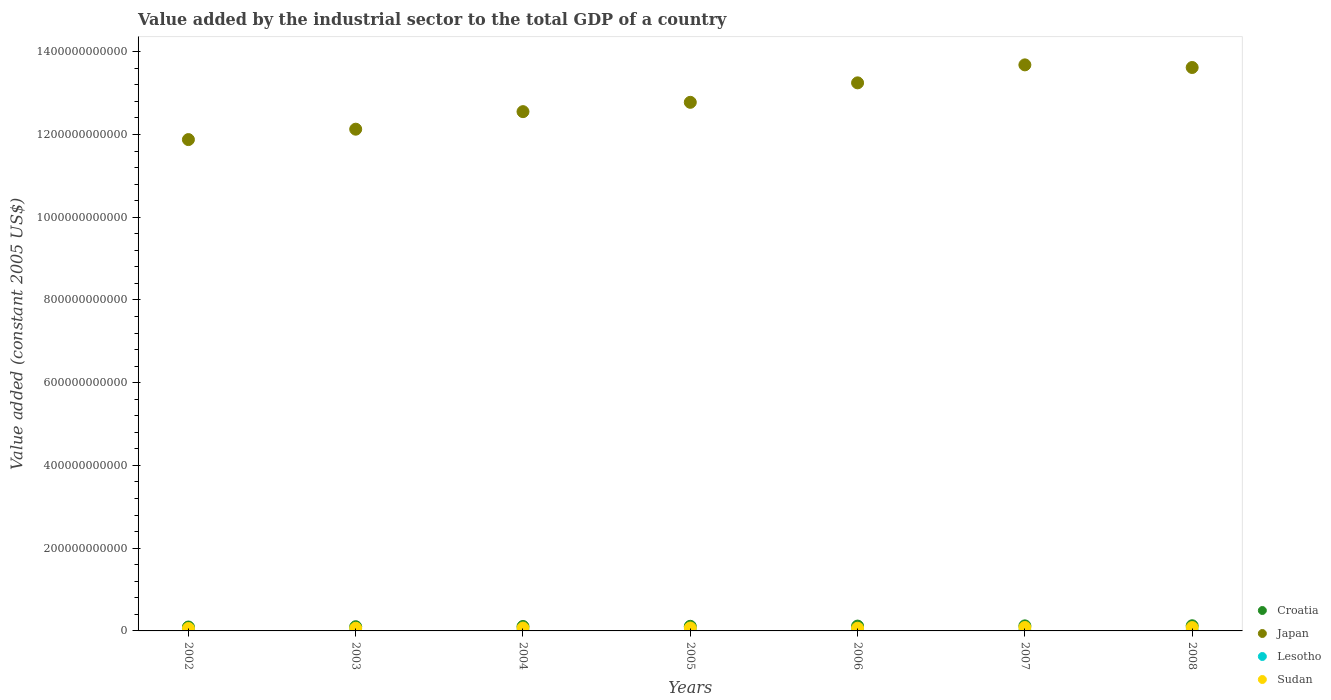Is the number of dotlines equal to the number of legend labels?
Keep it short and to the point. Yes. What is the value added by the industrial sector in Japan in 2007?
Ensure brevity in your answer.  1.37e+12. Across all years, what is the maximum value added by the industrial sector in Croatia?
Provide a short and direct response. 1.25e+1. Across all years, what is the minimum value added by the industrial sector in Croatia?
Your response must be concise. 9.44e+09. In which year was the value added by the industrial sector in Lesotho maximum?
Give a very brief answer. 2008. In which year was the value added by the industrial sector in Croatia minimum?
Keep it short and to the point. 2002. What is the total value added by the industrial sector in Lesotho in the graph?
Keep it short and to the point. 3.04e+09. What is the difference between the value added by the industrial sector in Sudan in 2003 and that in 2008?
Your response must be concise. -1.58e+09. What is the difference between the value added by the industrial sector in Japan in 2004 and the value added by the industrial sector in Lesotho in 2007?
Provide a succinct answer. 1.25e+12. What is the average value added by the industrial sector in Sudan per year?
Offer a terse response. 7.08e+09. In the year 2005, what is the difference between the value added by the industrial sector in Croatia and value added by the industrial sector in Japan?
Provide a short and direct response. -1.27e+12. In how many years, is the value added by the industrial sector in Lesotho greater than 240000000000 US$?
Your answer should be very brief. 0. What is the ratio of the value added by the industrial sector in Japan in 2005 to that in 2007?
Provide a succinct answer. 0.93. What is the difference between the highest and the second highest value added by the industrial sector in Sudan?
Offer a very short reply. 1.74e+08. What is the difference between the highest and the lowest value added by the industrial sector in Croatia?
Make the answer very short. 3.04e+09. In how many years, is the value added by the industrial sector in Japan greater than the average value added by the industrial sector in Japan taken over all years?
Provide a succinct answer. 3. Is the value added by the industrial sector in Croatia strictly greater than the value added by the industrial sector in Japan over the years?
Your answer should be compact. No. How many dotlines are there?
Make the answer very short. 4. What is the difference between two consecutive major ticks on the Y-axis?
Your answer should be very brief. 2.00e+11. Does the graph contain grids?
Offer a terse response. No. Where does the legend appear in the graph?
Your answer should be compact. Bottom right. How many legend labels are there?
Your answer should be compact. 4. What is the title of the graph?
Offer a terse response. Value added by the industrial sector to the total GDP of a country. What is the label or title of the X-axis?
Ensure brevity in your answer.  Years. What is the label or title of the Y-axis?
Keep it short and to the point. Value added (constant 2005 US$). What is the Value added (constant 2005 US$) in Croatia in 2002?
Offer a terse response. 9.44e+09. What is the Value added (constant 2005 US$) in Japan in 2002?
Keep it short and to the point. 1.19e+12. What is the Value added (constant 2005 US$) in Lesotho in 2002?
Keep it short and to the point. 3.73e+08. What is the Value added (constant 2005 US$) in Sudan in 2002?
Ensure brevity in your answer.  5.91e+09. What is the Value added (constant 2005 US$) of Croatia in 2003?
Ensure brevity in your answer.  1.02e+1. What is the Value added (constant 2005 US$) in Japan in 2003?
Your answer should be very brief. 1.21e+12. What is the Value added (constant 2005 US$) in Lesotho in 2003?
Your answer should be compact. 4.09e+08. What is the Value added (constant 2005 US$) in Sudan in 2003?
Your answer should be very brief. 6.54e+09. What is the Value added (constant 2005 US$) in Croatia in 2004?
Your answer should be very brief. 1.08e+1. What is the Value added (constant 2005 US$) of Japan in 2004?
Give a very brief answer. 1.26e+12. What is the Value added (constant 2005 US$) of Lesotho in 2004?
Make the answer very short. 4.16e+08. What is the Value added (constant 2005 US$) in Sudan in 2004?
Offer a terse response. 6.93e+09. What is the Value added (constant 2005 US$) in Croatia in 2005?
Provide a short and direct response. 1.12e+1. What is the Value added (constant 2005 US$) in Japan in 2005?
Your response must be concise. 1.28e+12. What is the Value added (constant 2005 US$) of Lesotho in 2005?
Provide a short and direct response. 4.16e+08. What is the Value added (constant 2005 US$) of Sudan in 2005?
Offer a terse response. 7.13e+09. What is the Value added (constant 2005 US$) of Croatia in 2006?
Your response must be concise. 1.17e+1. What is the Value added (constant 2005 US$) of Japan in 2006?
Your answer should be very brief. 1.32e+12. What is the Value added (constant 2005 US$) in Lesotho in 2006?
Make the answer very short. 4.47e+08. What is the Value added (constant 2005 US$) in Sudan in 2006?
Provide a short and direct response. 6.63e+09. What is the Value added (constant 2005 US$) in Croatia in 2007?
Provide a short and direct response. 1.22e+1. What is the Value added (constant 2005 US$) of Japan in 2007?
Your answer should be very brief. 1.37e+12. What is the Value added (constant 2005 US$) of Lesotho in 2007?
Your answer should be compact. 4.77e+08. What is the Value added (constant 2005 US$) in Sudan in 2007?
Make the answer very short. 8.29e+09. What is the Value added (constant 2005 US$) in Croatia in 2008?
Keep it short and to the point. 1.25e+1. What is the Value added (constant 2005 US$) of Japan in 2008?
Give a very brief answer. 1.36e+12. What is the Value added (constant 2005 US$) of Lesotho in 2008?
Your response must be concise. 5.03e+08. What is the Value added (constant 2005 US$) in Sudan in 2008?
Your answer should be compact. 8.12e+09. Across all years, what is the maximum Value added (constant 2005 US$) in Croatia?
Provide a short and direct response. 1.25e+1. Across all years, what is the maximum Value added (constant 2005 US$) in Japan?
Your response must be concise. 1.37e+12. Across all years, what is the maximum Value added (constant 2005 US$) of Lesotho?
Provide a short and direct response. 5.03e+08. Across all years, what is the maximum Value added (constant 2005 US$) in Sudan?
Your answer should be compact. 8.29e+09. Across all years, what is the minimum Value added (constant 2005 US$) in Croatia?
Make the answer very short. 9.44e+09. Across all years, what is the minimum Value added (constant 2005 US$) of Japan?
Provide a short and direct response. 1.19e+12. Across all years, what is the minimum Value added (constant 2005 US$) of Lesotho?
Provide a short and direct response. 3.73e+08. Across all years, what is the minimum Value added (constant 2005 US$) of Sudan?
Ensure brevity in your answer.  5.91e+09. What is the total Value added (constant 2005 US$) in Croatia in the graph?
Provide a succinct answer. 7.79e+1. What is the total Value added (constant 2005 US$) in Japan in the graph?
Provide a short and direct response. 8.99e+12. What is the total Value added (constant 2005 US$) in Lesotho in the graph?
Your answer should be compact. 3.04e+09. What is the total Value added (constant 2005 US$) in Sudan in the graph?
Give a very brief answer. 4.96e+1. What is the difference between the Value added (constant 2005 US$) in Croatia in 2002 and that in 2003?
Ensure brevity in your answer.  -7.32e+08. What is the difference between the Value added (constant 2005 US$) in Japan in 2002 and that in 2003?
Offer a very short reply. -2.51e+1. What is the difference between the Value added (constant 2005 US$) in Lesotho in 2002 and that in 2003?
Give a very brief answer. -3.61e+07. What is the difference between the Value added (constant 2005 US$) of Sudan in 2002 and that in 2003?
Ensure brevity in your answer.  -6.27e+08. What is the difference between the Value added (constant 2005 US$) in Croatia in 2002 and that in 2004?
Keep it short and to the point. -1.32e+09. What is the difference between the Value added (constant 2005 US$) in Japan in 2002 and that in 2004?
Offer a very short reply. -6.75e+1. What is the difference between the Value added (constant 2005 US$) in Lesotho in 2002 and that in 2004?
Provide a succinct answer. -4.29e+07. What is the difference between the Value added (constant 2005 US$) in Sudan in 2002 and that in 2004?
Ensure brevity in your answer.  -1.02e+09. What is the difference between the Value added (constant 2005 US$) of Croatia in 2002 and that in 2005?
Provide a short and direct response. -1.73e+09. What is the difference between the Value added (constant 2005 US$) in Japan in 2002 and that in 2005?
Your answer should be very brief. -9.01e+1. What is the difference between the Value added (constant 2005 US$) of Lesotho in 2002 and that in 2005?
Your response must be concise. -4.34e+07. What is the difference between the Value added (constant 2005 US$) of Sudan in 2002 and that in 2005?
Offer a terse response. -1.22e+09. What is the difference between the Value added (constant 2005 US$) of Croatia in 2002 and that in 2006?
Offer a terse response. -2.24e+09. What is the difference between the Value added (constant 2005 US$) in Japan in 2002 and that in 2006?
Keep it short and to the point. -1.37e+11. What is the difference between the Value added (constant 2005 US$) in Lesotho in 2002 and that in 2006?
Your response must be concise. -7.40e+07. What is the difference between the Value added (constant 2005 US$) of Sudan in 2002 and that in 2006?
Your answer should be very brief. -7.18e+08. What is the difference between the Value added (constant 2005 US$) of Croatia in 2002 and that in 2007?
Your answer should be very brief. -2.79e+09. What is the difference between the Value added (constant 2005 US$) of Japan in 2002 and that in 2007?
Your answer should be very brief. -1.81e+11. What is the difference between the Value added (constant 2005 US$) in Lesotho in 2002 and that in 2007?
Give a very brief answer. -1.04e+08. What is the difference between the Value added (constant 2005 US$) of Sudan in 2002 and that in 2007?
Provide a succinct answer. -2.38e+09. What is the difference between the Value added (constant 2005 US$) of Croatia in 2002 and that in 2008?
Offer a terse response. -3.04e+09. What is the difference between the Value added (constant 2005 US$) in Japan in 2002 and that in 2008?
Your answer should be compact. -1.74e+11. What is the difference between the Value added (constant 2005 US$) in Lesotho in 2002 and that in 2008?
Your answer should be very brief. -1.30e+08. What is the difference between the Value added (constant 2005 US$) in Sudan in 2002 and that in 2008?
Make the answer very short. -2.21e+09. What is the difference between the Value added (constant 2005 US$) of Croatia in 2003 and that in 2004?
Make the answer very short. -5.92e+08. What is the difference between the Value added (constant 2005 US$) of Japan in 2003 and that in 2004?
Provide a short and direct response. -4.24e+1. What is the difference between the Value added (constant 2005 US$) of Lesotho in 2003 and that in 2004?
Your answer should be very brief. -6.88e+06. What is the difference between the Value added (constant 2005 US$) of Sudan in 2003 and that in 2004?
Offer a terse response. -3.95e+08. What is the difference between the Value added (constant 2005 US$) of Croatia in 2003 and that in 2005?
Ensure brevity in your answer.  -9.95e+08. What is the difference between the Value added (constant 2005 US$) in Japan in 2003 and that in 2005?
Your answer should be very brief. -6.49e+1. What is the difference between the Value added (constant 2005 US$) in Lesotho in 2003 and that in 2005?
Make the answer very short. -7.39e+06. What is the difference between the Value added (constant 2005 US$) of Sudan in 2003 and that in 2005?
Your answer should be compact. -5.90e+08. What is the difference between the Value added (constant 2005 US$) of Croatia in 2003 and that in 2006?
Keep it short and to the point. -1.51e+09. What is the difference between the Value added (constant 2005 US$) of Japan in 2003 and that in 2006?
Your response must be concise. -1.12e+11. What is the difference between the Value added (constant 2005 US$) in Lesotho in 2003 and that in 2006?
Ensure brevity in your answer.  -3.79e+07. What is the difference between the Value added (constant 2005 US$) of Sudan in 2003 and that in 2006?
Make the answer very short. -9.01e+07. What is the difference between the Value added (constant 2005 US$) in Croatia in 2003 and that in 2007?
Your answer should be compact. -2.06e+09. What is the difference between the Value added (constant 2005 US$) of Japan in 2003 and that in 2007?
Give a very brief answer. -1.55e+11. What is the difference between the Value added (constant 2005 US$) of Lesotho in 2003 and that in 2007?
Offer a terse response. -6.76e+07. What is the difference between the Value added (constant 2005 US$) of Sudan in 2003 and that in 2007?
Ensure brevity in your answer.  -1.75e+09. What is the difference between the Value added (constant 2005 US$) of Croatia in 2003 and that in 2008?
Keep it short and to the point. -2.31e+09. What is the difference between the Value added (constant 2005 US$) of Japan in 2003 and that in 2008?
Your answer should be compact. -1.49e+11. What is the difference between the Value added (constant 2005 US$) in Lesotho in 2003 and that in 2008?
Offer a very short reply. -9.36e+07. What is the difference between the Value added (constant 2005 US$) of Sudan in 2003 and that in 2008?
Provide a short and direct response. -1.58e+09. What is the difference between the Value added (constant 2005 US$) of Croatia in 2004 and that in 2005?
Provide a succinct answer. -4.03e+08. What is the difference between the Value added (constant 2005 US$) of Japan in 2004 and that in 2005?
Your answer should be compact. -2.25e+1. What is the difference between the Value added (constant 2005 US$) in Lesotho in 2004 and that in 2005?
Give a very brief answer. -5.01e+05. What is the difference between the Value added (constant 2005 US$) in Sudan in 2004 and that in 2005?
Your response must be concise. -1.94e+08. What is the difference between the Value added (constant 2005 US$) of Croatia in 2004 and that in 2006?
Give a very brief answer. -9.14e+08. What is the difference between the Value added (constant 2005 US$) in Japan in 2004 and that in 2006?
Provide a succinct answer. -6.96e+1. What is the difference between the Value added (constant 2005 US$) of Lesotho in 2004 and that in 2006?
Ensure brevity in your answer.  -3.11e+07. What is the difference between the Value added (constant 2005 US$) in Sudan in 2004 and that in 2006?
Offer a terse response. 3.05e+08. What is the difference between the Value added (constant 2005 US$) of Croatia in 2004 and that in 2007?
Offer a very short reply. -1.47e+09. What is the difference between the Value added (constant 2005 US$) in Japan in 2004 and that in 2007?
Offer a terse response. -1.13e+11. What is the difference between the Value added (constant 2005 US$) in Lesotho in 2004 and that in 2007?
Keep it short and to the point. -6.08e+07. What is the difference between the Value added (constant 2005 US$) of Sudan in 2004 and that in 2007?
Your response must be concise. -1.36e+09. What is the difference between the Value added (constant 2005 US$) of Croatia in 2004 and that in 2008?
Keep it short and to the point. -1.72e+09. What is the difference between the Value added (constant 2005 US$) of Japan in 2004 and that in 2008?
Offer a very short reply. -1.07e+11. What is the difference between the Value added (constant 2005 US$) in Lesotho in 2004 and that in 2008?
Your answer should be compact. -8.67e+07. What is the difference between the Value added (constant 2005 US$) of Sudan in 2004 and that in 2008?
Your answer should be compact. -1.18e+09. What is the difference between the Value added (constant 2005 US$) in Croatia in 2005 and that in 2006?
Offer a terse response. -5.11e+08. What is the difference between the Value added (constant 2005 US$) of Japan in 2005 and that in 2006?
Make the answer very short. -4.71e+1. What is the difference between the Value added (constant 2005 US$) in Lesotho in 2005 and that in 2006?
Make the answer very short. -3.06e+07. What is the difference between the Value added (constant 2005 US$) of Sudan in 2005 and that in 2006?
Provide a succinct answer. 5.00e+08. What is the difference between the Value added (constant 2005 US$) in Croatia in 2005 and that in 2007?
Provide a short and direct response. -1.07e+09. What is the difference between the Value added (constant 2005 US$) in Japan in 2005 and that in 2007?
Give a very brief answer. -9.05e+1. What is the difference between the Value added (constant 2005 US$) in Lesotho in 2005 and that in 2007?
Provide a succinct answer. -6.03e+07. What is the difference between the Value added (constant 2005 US$) of Sudan in 2005 and that in 2007?
Your answer should be very brief. -1.16e+09. What is the difference between the Value added (constant 2005 US$) in Croatia in 2005 and that in 2008?
Provide a short and direct response. -1.32e+09. What is the difference between the Value added (constant 2005 US$) in Japan in 2005 and that in 2008?
Provide a succinct answer. -8.42e+1. What is the difference between the Value added (constant 2005 US$) of Lesotho in 2005 and that in 2008?
Keep it short and to the point. -8.62e+07. What is the difference between the Value added (constant 2005 US$) of Sudan in 2005 and that in 2008?
Make the answer very short. -9.90e+08. What is the difference between the Value added (constant 2005 US$) in Croatia in 2006 and that in 2007?
Ensure brevity in your answer.  -5.57e+08. What is the difference between the Value added (constant 2005 US$) of Japan in 2006 and that in 2007?
Provide a succinct answer. -4.35e+1. What is the difference between the Value added (constant 2005 US$) in Lesotho in 2006 and that in 2007?
Your answer should be very brief. -2.97e+07. What is the difference between the Value added (constant 2005 US$) of Sudan in 2006 and that in 2007?
Make the answer very short. -1.66e+09. What is the difference between the Value added (constant 2005 US$) in Croatia in 2006 and that in 2008?
Keep it short and to the point. -8.07e+08. What is the difference between the Value added (constant 2005 US$) in Japan in 2006 and that in 2008?
Your answer should be very brief. -3.71e+1. What is the difference between the Value added (constant 2005 US$) of Lesotho in 2006 and that in 2008?
Provide a succinct answer. -5.56e+07. What is the difference between the Value added (constant 2005 US$) of Sudan in 2006 and that in 2008?
Provide a succinct answer. -1.49e+09. What is the difference between the Value added (constant 2005 US$) in Croatia in 2007 and that in 2008?
Offer a terse response. -2.50e+08. What is the difference between the Value added (constant 2005 US$) of Japan in 2007 and that in 2008?
Keep it short and to the point. 6.36e+09. What is the difference between the Value added (constant 2005 US$) in Lesotho in 2007 and that in 2008?
Your answer should be very brief. -2.59e+07. What is the difference between the Value added (constant 2005 US$) of Sudan in 2007 and that in 2008?
Offer a terse response. 1.74e+08. What is the difference between the Value added (constant 2005 US$) in Croatia in 2002 and the Value added (constant 2005 US$) in Japan in 2003?
Your answer should be compact. -1.20e+12. What is the difference between the Value added (constant 2005 US$) of Croatia in 2002 and the Value added (constant 2005 US$) of Lesotho in 2003?
Your response must be concise. 9.03e+09. What is the difference between the Value added (constant 2005 US$) of Croatia in 2002 and the Value added (constant 2005 US$) of Sudan in 2003?
Offer a very short reply. 2.90e+09. What is the difference between the Value added (constant 2005 US$) of Japan in 2002 and the Value added (constant 2005 US$) of Lesotho in 2003?
Your response must be concise. 1.19e+12. What is the difference between the Value added (constant 2005 US$) of Japan in 2002 and the Value added (constant 2005 US$) of Sudan in 2003?
Offer a very short reply. 1.18e+12. What is the difference between the Value added (constant 2005 US$) in Lesotho in 2002 and the Value added (constant 2005 US$) in Sudan in 2003?
Your response must be concise. -6.17e+09. What is the difference between the Value added (constant 2005 US$) in Croatia in 2002 and the Value added (constant 2005 US$) in Japan in 2004?
Your answer should be compact. -1.25e+12. What is the difference between the Value added (constant 2005 US$) of Croatia in 2002 and the Value added (constant 2005 US$) of Lesotho in 2004?
Offer a very short reply. 9.02e+09. What is the difference between the Value added (constant 2005 US$) of Croatia in 2002 and the Value added (constant 2005 US$) of Sudan in 2004?
Provide a succinct answer. 2.50e+09. What is the difference between the Value added (constant 2005 US$) of Japan in 2002 and the Value added (constant 2005 US$) of Lesotho in 2004?
Give a very brief answer. 1.19e+12. What is the difference between the Value added (constant 2005 US$) of Japan in 2002 and the Value added (constant 2005 US$) of Sudan in 2004?
Provide a short and direct response. 1.18e+12. What is the difference between the Value added (constant 2005 US$) in Lesotho in 2002 and the Value added (constant 2005 US$) in Sudan in 2004?
Your answer should be very brief. -6.56e+09. What is the difference between the Value added (constant 2005 US$) of Croatia in 2002 and the Value added (constant 2005 US$) of Japan in 2005?
Give a very brief answer. -1.27e+12. What is the difference between the Value added (constant 2005 US$) of Croatia in 2002 and the Value added (constant 2005 US$) of Lesotho in 2005?
Give a very brief answer. 9.02e+09. What is the difference between the Value added (constant 2005 US$) in Croatia in 2002 and the Value added (constant 2005 US$) in Sudan in 2005?
Give a very brief answer. 2.31e+09. What is the difference between the Value added (constant 2005 US$) in Japan in 2002 and the Value added (constant 2005 US$) in Lesotho in 2005?
Provide a short and direct response. 1.19e+12. What is the difference between the Value added (constant 2005 US$) of Japan in 2002 and the Value added (constant 2005 US$) of Sudan in 2005?
Your answer should be compact. 1.18e+12. What is the difference between the Value added (constant 2005 US$) of Lesotho in 2002 and the Value added (constant 2005 US$) of Sudan in 2005?
Ensure brevity in your answer.  -6.76e+09. What is the difference between the Value added (constant 2005 US$) in Croatia in 2002 and the Value added (constant 2005 US$) in Japan in 2006?
Your answer should be very brief. -1.32e+12. What is the difference between the Value added (constant 2005 US$) of Croatia in 2002 and the Value added (constant 2005 US$) of Lesotho in 2006?
Keep it short and to the point. 8.99e+09. What is the difference between the Value added (constant 2005 US$) in Croatia in 2002 and the Value added (constant 2005 US$) in Sudan in 2006?
Provide a succinct answer. 2.81e+09. What is the difference between the Value added (constant 2005 US$) of Japan in 2002 and the Value added (constant 2005 US$) of Lesotho in 2006?
Keep it short and to the point. 1.19e+12. What is the difference between the Value added (constant 2005 US$) of Japan in 2002 and the Value added (constant 2005 US$) of Sudan in 2006?
Your response must be concise. 1.18e+12. What is the difference between the Value added (constant 2005 US$) of Lesotho in 2002 and the Value added (constant 2005 US$) of Sudan in 2006?
Provide a short and direct response. -6.26e+09. What is the difference between the Value added (constant 2005 US$) in Croatia in 2002 and the Value added (constant 2005 US$) in Japan in 2007?
Provide a succinct answer. -1.36e+12. What is the difference between the Value added (constant 2005 US$) of Croatia in 2002 and the Value added (constant 2005 US$) of Lesotho in 2007?
Give a very brief answer. 8.96e+09. What is the difference between the Value added (constant 2005 US$) of Croatia in 2002 and the Value added (constant 2005 US$) of Sudan in 2007?
Provide a succinct answer. 1.14e+09. What is the difference between the Value added (constant 2005 US$) in Japan in 2002 and the Value added (constant 2005 US$) in Lesotho in 2007?
Offer a terse response. 1.19e+12. What is the difference between the Value added (constant 2005 US$) of Japan in 2002 and the Value added (constant 2005 US$) of Sudan in 2007?
Ensure brevity in your answer.  1.18e+12. What is the difference between the Value added (constant 2005 US$) in Lesotho in 2002 and the Value added (constant 2005 US$) in Sudan in 2007?
Your response must be concise. -7.92e+09. What is the difference between the Value added (constant 2005 US$) in Croatia in 2002 and the Value added (constant 2005 US$) in Japan in 2008?
Keep it short and to the point. -1.35e+12. What is the difference between the Value added (constant 2005 US$) in Croatia in 2002 and the Value added (constant 2005 US$) in Lesotho in 2008?
Make the answer very short. 8.93e+09. What is the difference between the Value added (constant 2005 US$) of Croatia in 2002 and the Value added (constant 2005 US$) of Sudan in 2008?
Give a very brief answer. 1.32e+09. What is the difference between the Value added (constant 2005 US$) of Japan in 2002 and the Value added (constant 2005 US$) of Lesotho in 2008?
Provide a short and direct response. 1.19e+12. What is the difference between the Value added (constant 2005 US$) in Japan in 2002 and the Value added (constant 2005 US$) in Sudan in 2008?
Offer a very short reply. 1.18e+12. What is the difference between the Value added (constant 2005 US$) of Lesotho in 2002 and the Value added (constant 2005 US$) of Sudan in 2008?
Your answer should be compact. -7.75e+09. What is the difference between the Value added (constant 2005 US$) in Croatia in 2003 and the Value added (constant 2005 US$) in Japan in 2004?
Give a very brief answer. -1.25e+12. What is the difference between the Value added (constant 2005 US$) in Croatia in 2003 and the Value added (constant 2005 US$) in Lesotho in 2004?
Ensure brevity in your answer.  9.75e+09. What is the difference between the Value added (constant 2005 US$) in Croatia in 2003 and the Value added (constant 2005 US$) in Sudan in 2004?
Ensure brevity in your answer.  3.23e+09. What is the difference between the Value added (constant 2005 US$) in Japan in 2003 and the Value added (constant 2005 US$) in Lesotho in 2004?
Offer a very short reply. 1.21e+12. What is the difference between the Value added (constant 2005 US$) of Japan in 2003 and the Value added (constant 2005 US$) of Sudan in 2004?
Offer a very short reply. 1.21e+12. What is the difference between the Value added (constant 2005 US$) in Lesotho in 2003 and the Value added (constant 2005 US$) in Sudan in 2004?
Provide a succinct answer. -6.53e+09. What is the difference between the Value added (constant 2005 US$) of Croatia in 2003 and the Value added (constant 2005 US$) of Japan in 2005?
Offer a very short reply. -1.27e+12. What is the difference between the Value added (constant 2005 US$) of Croatia in 2003 and the Value added (constant 2005 US$) of Lesotho in 2005?
Your response must be concise. 9.75e+09. What is the difference between the Value added (constant 2005 US$) of Croatia in 2003 and the Value added (constant 2005 US$) of Sudan in 2005?
Keep it short and to the point. 3.04e+09. What is the difference between the Value added (constant 2005 US$) of Japan in 2003 and the Value added (constant 2005 US$) of Lesotho in 2005?
Give a very brief answer. 1.21e+12. What is the difference between the Value added (constant 2005 US$) of Japan in 2003 and the Value added (constant 2005 US$) of Sudan in 2005?
Your answer should be very brief. 1.21e+12. What is the difference between the Value added (constant 2005 US$) in Lesotho in 2003 and the Value added (constant 2005 US$) in Sudan in 2005?
Your answer should be compact. -6.72e+09. What is the difference between the Value added (constant 2005 US$) in Croatia in 2003 and the Value added (constant 2005 US$) in Japan in 2006?
Make the answer very short. -1.31e+12. What is the difference between the Value added (constant 2005 US$) of Croatia in 2003 and the Value added (constant 2005 US$) of Lesotho in 2006?
Your response must be concise. 9.72e+09. What is the difference between the Value added (constant 2005 US$) in Croatia in 2003 and the Value added (constant 2005 US$) in Sudan in 2006?
Your answer should be very brief. 3.54e+09. What is the difference between the Value added (constant 2005 US$) of Japan in 2003 and the Value added (constant 2005 US$) of Lesotho in 2006?
Offer a terse response. 1.21e+12. What is the difference between the Value added (constant 2005 US$) of Japan in 2003 and the Value added (constant 2005 US$) of Sudan in 2006?
Provide a short and direct response. 1.21e+12. What is the difference between the Value added (constant 2005 US$) in Lesotho in 2003 and the Value added (constant 2005 US$) in Sudan in 2006?
Give a very brief answer. -6.22e+09. What is the difference between the Value added (constant 2005 US$) of Croatia in 2003 and the Value added (constant 2005 US$) of Japan in 2007?
Ensure brevity in your answer.  -1.36e+12. What is the difference between the Value added (constant 2005 US$) in Croatia in 2003 and the Value added (constant 2005 US$) in Lesotho in 2007?
Give a very brief answer. 9.69e+09. What is the difference between the Value added (constant 2005 US$) of Croatia in 2003 and the Value added (constant 2005 US$) of Sudan in 2007?
Make the answer very short. 1.87e+09. What is the difference between the Value added (constant 2005 US$) in Japan in 2003 and the Value added (constant 2005 US$) in Lesotho in 2007?
Your response must be concise. 1.21e+12. What is the difference between the Value added (constant 2005 US$) in Japan in 2003 and the Value added (constant 2005 US$) in Sudan in 2007?
Your answer should be compact. 1.20e+12. What is the difference between the Value added (constant 2005 US$) of Lesotho in 2003 and the Value added (constant 2005 US$) of Sudan in 2007?
Keep it short and to the point. -7.88e+09. What is the difference between the Value added (constant 2005 US$) of Croatia in 2003 and the Value added (constant 2005 US$) of Japan in 2008?
Give a very brief answer. -1.35e+12. What is the difference between the Value added (constant 2005 US$) of Croatia in 2003 and the Value added (constant 2005 US$) of Lesotho in 2008?
Keep it short and to the point. 9.67e+09. What is the difference between the Value added (constant 2005 US$) in Croatia in 2003 and the Value added (constant 2005 US$) in Sudan in 2008?
Make the answer very short. 2.05e+09. What is the difference between the Value added (constant 2005 US$) of Japan in 2003 and the Value added (constant 2005 US$) of Lesotho in 2008?
Offer a very short reply. 1.21e+12. What is the difference between the Value added (constant 2005 US$) of Japan in 2003 and the Value added (constant 2005 US$) of Sudan in 2008?
Ensure brevity in your answer.  1.20e+12. What is the difference between the Value added (constant 2005 US$) in Lesotho in 2003 and the Value added (constant 2005 US$) in Sudan in 2008?
Provide a short and direct response. -7.71e+09. What is the difference between the Value added (constant 2005 US$) in Croatia in 2004 and the Value added (constant 2005 US$) in Japan in 2005?
Your answer should be very brief. -1.27e+12. What is the difference between the Value added (constant 2005 US$) in Croatia in 2004 and the Value added (constant 2005 US$) in Lesotho in 2005?
Give a very brief answer. 1.03e+1. What is the difference between the Value added (constant 2005 US$) of Croatia in 2004 and the Value added (constant 2005 US$) of Sudan in 2005?
Your answer should be compact. 3.63e+09. What is the difference between the Value added (constant 2005 US$) of Japan in 2004 and the Value added (constant 2005 US$) of Lesotho in 2005?
Your answer should be compact. 1.25e+12. What is the difference between the Value added (constant 2005 US$) in Japan in 2004 and the Value added (constant 2005 US$) in Sudan in 2005?
Ensure brevity in your answer.  1.25e+12. What is the difference between the Value added (constant 2005 US$) of Lesotho in 2004 and the Value added (constant 2005 US$) of Sudan in 2005?
Offer a terse response. -6.71e+09. What is the difference between the Value added (constant 2005 US$) of Croatia in 2004 and the Value added (constant 2005 US$) of Japan in 2006?
Offer a terse response. -1.31e+12. What is the difference between the Value added (constant 2005 US$) in Croatia in 2004 and the Value added (constant 2005 US$) in Lesotho in 2006?
Provide a short and direct response. 1.03e+1. What is the difference between the Value added (constant 2005 US$) in Croatia in 2004 and the Value added (constant 2005 US$) in Sudan in 2006?
Ensure brevity in your answer.  4.13e+09. What is the difference between the Value added (constant 2005 US$) of Japan in 2004 and the Value added (constant 2005 US$) of Lesotho in 2006?
Provide a succinct answer. 1.25e+12. What is the difference between the Value added (constant 2005 US$) of Japan in 2004 and the Value added (constant 2005 US$) of Sudan in 2006?
Your answer should be compact. 1.25e+12. What is the difference between the Value added (constant 2005 US$) in Lesotho in 2004 and the Value added (constant 2005 US$) in Sudan in 2006?
Ensure brevity in your answer.  -6.21e+09. What is the difference between the Value added (constant 2005 US$) of Croatia in 2004 and the Value added (constant 2005 US$) of Japan in 2007?
Provide a succinct answer. -1.36e+12. What is the difference between the Value added (constant 2005 US$) of Croatia in 2004 and the Value added (constant 2005 US$) of Lesotho in 2007?
Offer a very short reply. 1.03e+1. What is the difference between the Value added (constant 2005 US$) of Croatia in 2004 and the Value added (constant 2005 US$) of Sudan in 2007?
Your answer should be compact. 2.47e+09. What is the difference between the Value added (constant 2005 US$) in Japan in 2004 and the Value added (constant 2005 US$) in Lesotho in 2007?
Your response must be concise. 1.25e+12. What is the difference between the Value added (constant 2005 US$) of Japan in 2004 and the Value added (constant 2005 US$) of Sudan in 2007?
Offer a terse response. 1.25e+12. What is the difference between the Value added (constant 2005 US$) in Lesotho in 2004 and the Value added (constant 2005 US$) in Sudan in 2007?
Give a very brief answer. -7.88e+09. What is the difference between the Value added (constant 2005 US$) of Croatia in 2004 and the Value added (constant 2005 US$) of Japan in 2008?
Provide a succinct answer. -1.35e+12. What is the difference between the Value added (constant 2005 US$) of Croatia in 2004 and the Value added (constant 2005 US$) of Lesotho in 2008?
Keep it short and to the point. 1.03e+1. What is the difference between the Value added (constant 2005 US$) in Croatia in 2004 and the Value added (constant 2005 US$) in Sudan in 2008?
Your answer should be very brief. 2.64e+09. What is the difference between the Value added (constant 2005 US$) of Japan in 2004 and the Value added (constant 2005 US$) of Lesotho in 2008?
Your answer should be compact. 1.25e+12. What is the difference between the Value added (constant 2005 US$) of Japan in 2004 and the Value added (constant 2005 US$) of Sudan in 2008?
Provide a short and direct response. 1.25e+12. What is the difference between the Value added (constant 2005 US$) of Lesotho in 2004 and the Value added (constant 2005 US$) of Sudan in 2008?
Make the answer very short. -7.70e+09. What is the difference between the Value added (constant 2005 US$) in Croatia in 2005 and the Value added (constant 2005 US$) in Japan in 2006?
Keep it short and to the point. -1.31e+12. What is the difference between the Value added (constant 2005 US$) in Croatia in 2005 and the Value added (constant 2005 US$) in Lesotho in 2006?
Give a very brief answer. 1.07e+1. What is the difference between the Value added (constant 2005 US$) in Croatia in 2005 and the Value added (constant 2005 US$) in Sudan in 2006?
Your response must be concise. 4.53e+09. What is the difference between the Value added (constant 2005 US$) of Japan in 2005 and the Value added (constant 2005 US$) of Lesotho in 2006?
Your response must be concise. 1.28e+12. What is the difference between the Value added (constant 2005 US$) of Japan in 2005 and the Value added (constant 2005 US$) of Sudan in 2006?
Your response must be concise. 1.27e+12. What is the difference between the Value added (constant 2005 US$) in Lesotho in 2005 and the Value added (constant 2005 US$) in Sudan in 2006?
Offer a very short reply. -6.21e+09. What is the difference between the Value added (constant 2005 US$) in Croatia in 2005 and the Value added (constant 2005 US$) in Japan in 2007?
Your response must be concise. -1.36e+12. What is the difference between the Value added (constant 2005 US$) in Croatia in 2005 and the Value added (constant 2005 US$) in Lesotho in 2007?
Offer a very short reply. 1.07e+1. What is the difference between the Value added (constant 2005 US$) of Croatia in 2005 and the Value added (constant 2005 US$) of Sudan in 2007?
Offer a very short reply. 2.87e+09. What is the difference between the Value added (constant 2005 US$) of Japan in 2005 and the Value added (constant 2005 US$) of Lesotho in 2007?
Ensure brevity in your answer.  1.28e+12. What is the difference between the Value added (constant 2005 US$) of Japan in 2005 and the Value added (constant 2005 US$) of Sudan in 2007?
Your answer should be very brief. 1.27e+12. What is the difference between the Value added (constant 2005 US$) of Lesotho in 2005 and the Value added (constant 2005 US$) of Sudan in 2007?
Keep it short and to the point. -7.88e+09. What is the difference between the Value added (constant 2005 US$) in Croatia in 2005 and the Value added (constant 2005 US$) in Japan in 2008?
Your answer should be very brief. -1.35e+12. What is the difference between the Value added (constant 2005 US$) of Croatia in 2005 and the Value added (constant 2005 US$) of Lesotho in 2008?
Make the answer very short. 1.07e+1. What is the difference between the Value added (constant 2005 US$) in Croatia in 2005 and the Value added (constant 2005 US$) in Sudan in 2008?
Offer a terse response. 3.04e+09. What is the difference between the Value added (constant 2005 US$) in Japan in 2005 and the Value added (constant 2005 US$) in Lesotho in 2008?
Provide a succinct answer. 1.28e+12. What is the difference between the Value added (constant 2005 US$) in Japan in 2005 and the Value added (constant 2005 US$) in Sudan in 2008?
Keep it short and to the point. 1.27e+12. What is the difference between the Value added (constant 2005 US$) of Lesotho in 2005 and the Value added (constant 2005 US$) of Sudan in 2008?
Provide a short and direct response. -7.70e+09. What is the difference between the Value added (constant 2005 US$) in Croatia in 2006 and the Value added (constant 2005 US$) in Japan in 2007?
Make the answer very short. -1.36e+12. What is the difference between the Value added (constant 2005 US$) of Croatia in 2006 and the Value added (constant 2005 US$) of Lesotho in 2007?
Your answer should be compact. 1.12e+1. What is the difference between the Value added (constant 2005 US$) in Croatia in 2006 and the Value added (constant 2005 US$) in Sudan in 2007?
Your answer should be very brief. 3.38e+09. What is the difference between the Value added (constant 2005 US$) of Japan in 2006 and the Value added (constant 2005 US$) of Lesotho in 2007?
Give a very brief answer. 1.32e+12. What is the difference between the Value added (constant 2005 US$) of Japan in 2006 and the Value added (constant 2005 US$) of Sudan in 2007?
Your answer should be very brief. 1.32e+12. What is the difference between the Value added (constant 2005 US$) in Lesotho in 2006 and the Value added (constant 2005 US$) in Sudan in 2007?
Your answer should be very brief. -7.85e+09. What is the difference between the Value added (constant 2005 US$) of Croatia in 2006 and the Value added (constant 2005 US$) of Japan in 2008?
Your answer should be compact. -1.35e+12. What is the difference between the Value added (constant 2005 US$) of Croatia in 2006 and the Value added (constant 2005 US$) of Lesotho in 2008?
Offer a terse response. 1.12e+1. What is the difference between the Value added (constant 2005 US$) of Croatia in 2006 and the Value added (constant 2005 US$) of Sudan in 2008?
Offer a very short reply. 3.56e+09. What is the difference between the Value added (constant 2005 US$) in Japan in 2006 and the Value added (constant 2005 US$) in Lesotho in 2008?
Keep it short and to the point. 1.32e+12. What is the difference between the Value added (constant 2005 US$) of Japan in 2006 and the Value added (constant 2005 US$) of Sudan in 2008?
Give a very brief answer. 1.32e+12. What is the difference between the Value added (constant 2005 US$) of Lesotho in 2006 and the Value added (constant 2005 US$) of Sudan in 2008?
Offer a very short reply. -7.67e+09. What is the difference between the Value added (constant 2005 US$) of Croatia in 2007 and the Value added (constant 2005 US$) of Japan in 2008?
Your response must be concise. -1.35e+12. What is the difference between the Value added (constant 2005 US$) of Croatia in 2007 and the Value added (constant 2005 US$) of Lesotho in 2008?
Keep it short and to the point. 1.17e+1. What is the difference between the Value added (constant 2005 US$) of Croatia in 2007 and the Value added (constant 2005 US$) of Sudan in 2008?
Offer a very short reply. 4.11e+09. What is the difference between the Value added (constant 2005 US$) in Japan in 2007 and the Value added (constant 2005 US$) in Lesotho in 2008?
Make the answer very short. 1.37e+12. What is the difference between the Value added (constant 2005 US$) in Japan in 2007 and the Value added (constant 2005 US$) in Sudan in 2008?
Make the answer very short. 1.36e+12. What is the difference between the Value added (constant 2005 US$) in Lesotho in 2007 and the Value added (constant 2005 US$) in Sudan in 2008?
Your answer should be very brief. -7.64e+09. What is the average Value added (constant 2005 US$) in Croatia per year?
Ensure brevity in your answer.  1.11e+1. What is the average Value added (constant 2005 US$) in Japan per year?
Keep it short and to the point. 1.28e+12. What is the average Value added (constant 2005 US$) in Lesotho per year?
Your response must be concise. 4.34e+08. What is the average Value added (constant 2005 US$) of Sudan per year?
Provide a short and direct response. 7.08e+09. In the year 2002, what is the difference between the Value added (constant 2005 US$) of Croatia and Value added (constant 2005 US$) of Japan?
Keep it short and to the point. -1.18e+12. In the year 2002, what is the difference between the Value added (constant 2005 US$) in Croatia and Value added (constant 2005 US$) in Lesotho?
Ensure brevity in your answer.  9.06e+09. In the year 2002, what is the difference between the Value added (constant 2005 US$) in Croatia and Value added (constant 2005 US$) in Sudan?
Provide a short and direct response. 3.52e+09. In the year 2002, what is the difference between the Value added (constant 2005 US$) of Japan and Value added (constant 2005 US$) of Lesotho?
Give a very brief answer. 1.19e+12. In the year 2002, what is the difference between the Value added (constant 2005 US$) in Japan and Value added (constant 2005 US$) in Sudan?
Your response must be concise. 1.18e+12. In the year 2002, what is the difference between the Value added (constant 2005 US$) of Lesotho and Value added (constant 2005 US$) of Sudan?
Your answer should be compact. -5.54e+09. In the year 2003, what is the difference between the Value added (constant 2005 US$) of Croatia and Value added (constant 2005 US$) of Japan?
Your answer should be very brief. -1.20e+12. In the year 2003, what is the difference between the Value added (constant 2005 US$) in Croatia and Value added (constant 2005 US$) in Lesotho?
Provide a succinct answer. 9.76e+09. In the year 2003, what is the difference between the Value added (constant 2005 US$) in Croatia and Value added (constant 2005 US$) in Sudan?
Provide a short and direct response. 3.63e+09. In the year 2003, what is the difference between the Value added (constant 2005 US$) of Japan and Value added (constant 2005 US$) of Lesotho?
Keep it short and to the point. 1.21e+12. In the year 2003, what is the difference between the Value added (constant 2005 US$) in Japan and Value added (constant 2005 US$) in Sudan?
Offer a terse response. 1.21e+12. In the year 2003, what is the difference between the Value added (constant 2005 US$) of Lesotho and Value added (constant 2005 US$) of Sudan?
Give a very brief answer. -6.13e+09. In the year 2004, what is the difference between the Value added (constant 2005 US$) of Croatia and Value added (constant 2005 US$) of Japan?
Your answer should be compact. -1.24e+12. In the year 2004, what is the difference between the Value added (constant 2005 US$) in Croatia and Value added (constant 2005 US$) in Lesotho?
Your answer should be compact. 1.03e+1. In the year 2004, what is the difference between the Value added (constant 2005 US$) in Croatia and Value added (constant 2005 US$) in Sudan?
Ensure brevity in your answer.  3.83e+09. In the year 2004, what is the difference between the Value added (constant 2005 US$) of Japan and Value added (constant 2005 US$) of Lesotho?
Keep it short and to the point. 1.25e+12. In the year 2004, what is the difference between the Value added (constant 2005 US$) in Japan and Value added (constant 2005 US$) in Sudan?
Provide a succinct answer. 1.25e+12. In the year 2004, what is the difference between the Value added (constant 2005 US$) of Lesotho and Value added (constant 2005 US$) of Sudan?
Give a very brief answer. -6.52e+09. In the year 2005, what is the difference between the Value added (constant 2005 US$) of Croatia and Value added (constant 2005 US$) of Japan?
Ensure brevity in your answer.  -1.27e+12. In the year 2005, what is the difference between the Value added (constant 2005 US$) of Croatia and Value added (constant 2005 US$) of Lesotho?
Keep it short and to the point. 1.07e+1. In the year 2005, what is the difference between the Value added (constant 2005 US$) in Croatia and Value added (constant 2005 US$) in Sudan?
Your answer should be compact. 4.03e+09. In the year 2005, what is the difference between the Value added (constant 2005 US$) of Japan and Value added (constant 2005 US$) of Lesotho?
Give a very brief answer. 1.28e+12. In the year 2005, what is the difference between the Value added (constant 2005 US$) of Japan and Value added (constant 2005 US$) of Sudan?
Offer a terse response. 1.27e+12. In the year 2005, what is the difference between the Value added (constant 2005 US$) of Lesotho and Value added (constant 2005 US$) of Sudan?
Make the answer very short. -6.71e+09. In the year 2006, what is the difference between the Value added (constant 2005 US$) of Croatia and Value added (constant 2005 US$) of Japan?
Provide a short and direct response. -1.31e+12. In the year 2006, what is the difference between the Value added (constant 2005 US$) of Croatia and Value added (constant 2005 US$) of Lesotho?
Your answer should be compact. 1.12e+1. In the year 2006, what is the difference between the Value added (constant 2005 US$) in Croatia and Value added (constant 2005 US$) in Sudan?
Ensure brevity in your answer.  5.04e+09. In the year 2006, what is the difference between the Value added (constant 2005 US$) in Japan and Value added (constant 2005 US$) in Lesotho?
Your answer should be compact. 1.32e+12. In the year 2006, what is the difference between the Value added (constant 2005 US$) in Japan and Value added (constant 2005 US$) in Sudan?
Provide a short and direct response. 1.32e+12. In the year 2006, what is the difference between the Value added (constant 2005 US$) in Lesotho and Value added (constant 2005 US$) in Sudan?
Make the answer very short. -6.18e+09. In the year 2007, what is the difference between the Value added (constant 2005 US$) in Croatia and Value added (constant 2005 US$) in Japan?
Your answer should be compact. -1.36e+12. In the year 2007, what is the difference between the Value added (constant 2005 US$) of Croatia and Value added (constant 2005 US$) of Lesotho?
Keep it short and to the point. 1.18e+1. In the year 2007, what is the difference between the Value added (constant 2005 US$) in Croatia and Value added (constant 2005 US$) in Sudan?
Give a very brief answer. 3.94e+09. In the year 2007, what is the difference between the Value added (constant 2005 US$) in Japan and Value added (constant 2005 US$) in Lesotho?
Keep it short and to the point. 1.37e+12. In the year 2007, what is the difference between the Value added (constant 2005 US$) in Japan and Value added (constant 2005 US$) in Sudan?
Ensure brevity in your answer.  1.36e+12. In the year 2007, what is the difference between the Value added (constant 2005 US$) of Lesotho and Value added (constant 2005 US$) of Sudan?
Provide a succinct answer. -7.82e+09. In the year 2008, what is the difference between the Value added (constant 2005 US$) of Croatia and Value added (constant 2005 US$) of Japan?
Give a very brief answer. -1.35e+12. In the year 2008, what is the difference between the Value added (constant 2005 US$) of Croatia and Value added (constant 2005 US$) of Lesotho?
Provide a short and direct response. 1.20e+1. In the year 2008, what is the difference between the Value added (constant 2005 US$) of Croatia and Value added (constant 2005 US$) of Sudan?
Ensure brevity in your answer.  4.36e+09. In the year 2008, what is the difference between the Value added (constant 2005 US$) in Japan and Value added (constant 2005 US$) in Lesotho?
Keep it short and to the point. 1.36e+12. In the year 2008, what is the difference between the Value added (constant 2005 US$) of Japan and Value added (constant 2005 US$) of Sudan?
Keep it short and to the point. 1.35e+12. In the year 2008, what is the difference between the Value added (constant 2005 US$) in Lesotho and Value added (constant 2005 US$) in Sudan?
Provide a succinct answer. -7.62e+09. What is the ratio of the Value added (constant 2005 US$) in Croatia in 2002 to that in 2003?
Give a very brief answer. 0.93. What is the ratio of the Value added (constant 2005 US$) in Japan in 2002 to that in 2003?
Give a very brief answer. 0.98. What is the ratio of the Value added (constant 2005 US$) in Lesotho in 2002 to that in 2003?
Offer a very short reply. 0.91. What is the ratio of the Value added (constant 2005 US$) of Sudan in 2002 to that in 2003?
Offer a terse response. 0.9. What is the ratio of the Value added (constant 2005 US$) in Croatia in 2002 to that in 2004?
Provide a short and direct response. 0.88. What is the ratio of the Value added (constant 2005 US$) of Japan in 2002 to that in 2004?
Offer a very short reply. 0.95. What is the ratio of the Value added (constant 2005 US$) of Lesotho in 2002 to that in 2004?
Keep it short and to the point. 0.9. What is the ratio of the Value added (constant 2005 US$) of Sudan in 2002 to that in 2004?
Keep it short and to the point. 0.85. What is the ratio of the Value added (constant 2005 US$) of Croatia in 2002 to that in 2005?
Keep it short and to the point. 0.85. What is the ratio of the Value added (constant 2005 US$) of Japan in 2002 to that in 2005?
Give a very brief answer. 0.93. What is the ratio of the Value added (constant 2005 US$) in Lesotho in 2002 to that in 2005?
Ensure brevity in your answer.  0.9. What is the ratio of the Value added (constant 2005 US$) in Sudan in 2002 to that in 2005?
Provide a succinct answer. 0.83. What is the ratio of the Value added (constant 2005 US$) in Croatia in 2002 to that in 2006?
Provide a short and direct response. 0.81. What is the ratio of the Value added (constant 2005 US$) in Japan in 2002 to that in 2006?
Provide a short and direct response. 0.9. What is the ratio of the Value added (constant 2005 US$) of Lesotho in 2002 to that in 2006?
Your answer should be very brief. 0.83. What is the ratio of the Value added (constant 2005 US$) of Sudan in 2002 to that in 2006?
Your response must be concise. 0.89. What is the ratio of the Value added (constant 2005 US$) in Croatia in 2002 to that in 2007?
Provide a succinct answer. 0.77. What is the ratio of the Value added (constant 2005 US$) in Japan in 2002 to that in 2007?
Your answer should be very brief. 0.87. What is the ratio of the Value added (constant 2005 US$) in Lesotho in 2002 to that in 2007?
Ensure brevity in your answer.  0.78. What is the ratio of the Value added (constant 2005 US$) in Sudan in 2002 to that in 2007?
Ensure brevity in your answer.  0.71. What is the ratio of the Value added (constant 2005 US$) in Croatia in 2002 to that in 2008?
Ensure brevity in your answer.  0.76. What is the ratio of the Value added (constant 2005 US$) of Japan in 2002 to that in 2008?
Provide a short and direct response. 0.87. What is the ratio of the Value added (constant 2005 US$) of Lesotho in 2002 to that in 2008?
Ensure brevity in your answer.  0.74. What is the ratio of the Value added (constant 2005 US$) of Sudan in 2002 to that in 2008?
Ensure brevity in your answer.  0.73. What is the ratio of the Value added (constant 2005 US$) in Croatia in 2003 to that in 2004?
Offer a very short reply. 0.94. What is the ratio of the Value added (constant 2005 US$) in Japan in 2003 to that in 2004?
Your answer should be compact. 0.97. What is the ratio of the Value added (constant 2005 US$) in Lesotho in 2003 to that in 2004?
Provide a succinct answer. 0.98. What is the ratio of the Value added (constant 2005 US$) in Sudan in 2003 to that in 2004?
Keep it short and to the point. 0.94. What is the ratio of the Value added (constant 2005 US$) of Croatia in 2003 to that in 2005?
Make the answer very short. 0.91. What is the ratio of the Value added (constant 2005 US$) in Japan in 2003 to that in 2005?
Make the answer very short. 0.95. What is the ratio of the Value added (constant 2005 US$) in Lesotho in 2003 to that in 2005?
Offer a very short reply. 0.98. What is the ratio of the Value added (constant 2005 US$) of Sudan in 2003 to that in 2005?
Provide a succinct answer. 0.92. What is the ratio of the Value added (constant 2005 US$) in Croatia in 2003 to that in 2006?
Your response must be concise. 0.87. What is the ratio of the Value added (constant 2005 US$) in Japan in 2003 to that in 2006?
Provide a short and direct response. 0.92. What is the ratio of the Value added (constant 2005 US$) of Lesotho in 2003 to that in 2006?
Ensure brevity in your answer.  0.92. What is the ratio of the Value added (constant 2005 US$) in Sudan in 2003 to that in 2006?
Make the answer very short. 0.99. What is the ratio of the Value added (constant 2005 US$) in Croatia in 2003 to that in 2007?
Offer a terse response. 0.83. What is the ratio of the Value added (constant 2005 US$) of Japan in 2003 to that in 2007?
Make the answer very short. 0.89. What is the ratio of the Value added (constant 2005 US$) in Lesotho in 2003 to that in 2007?
Your response must be concise. 0.86. What is the ratio of the Value added (constant 2005 US$) of Sudan in 2003 to that in 2007?
Keep it short and to the point. 0.79. What is the ratio of the Value added (constant 2005 US$) of Croatia in 2003 to that in 2008?
Offer a very short reply. 0.81. What is the ratio of the Value added (constant 2005 US$) of Japan in 2003 to that in 2008?
Keep it short and to the point. 0.89. What is the ratio of the Value added (constant 2005 US$) of Lesotho in 2003 to that in 2008?
Keep it short and to the point. 0.81. What is the ratio of the Value added (constant 2005 US$) of Sudan in 2003 to that in 2008?
Offer a very short reply. 0.81. What is the ratio of the Value added (constant 2005 US$) in Croatia in 2004 to that in 2005?
Provide a short and direct response. 0.96. What is the ratio of the Value added (constant 2005 US$) in Japan in 2004 to that in 2005?
Make the answer very short. 0.98. What is the ratio of the Value added (constant 2005 US$) of Lesotho in 2004 to that in 2005?
Your answer should be very brief. 1. What is the ratio of the Value added (constant 2005 US$) of Sudan in 2004 to that in 2005?
Make the answer very short. 0.97. What is the ratio of the Value added (constant 2005 US$) of Croatia in 2004 to that in 2006?
Give a very brief answer. 0.92. What is the ratio of the Value added (constant 2005 US$) of Japan in 2004 to that in 2006?
Make the answer very short. 0.95. What is the ratio of the Value added (constant 2005 US$) of Lesotho in 2004 to that in 2006?
Give a very brief answer. 0.93. What is the ratio of the Value added (constant 2005 US$) of Sudan in 2004 to that in 2006?
Your response must be concise. 1.05. What is the ratio of the Value added (constant 2005 US$) in Croatia in 2004 to that in 2007?
Your answer should be compact. 0.88. What is the ratio of the Value added (constant 2005 US$) of Japan in 2004 to that in 2007?
Offer a terse response. 0.92. What is the ratio of the Value added (constant 2005 US$) in Lesotho in 2004 to that in 2007?
Your response must be concise. 0.87. What is the ratio of the Value added (constant 2005 US$) in Sudan in 2004 to that in 2007?
Your answer should be very brief. 0.84. What is the ratio of the Value added (constant 2005 US$) in Croatia in 2004 to that in 2008?
Give a very brief answer. 0.86. What is the ratio of the Value added (constant 2005 US$) of Japan in 2004 to that in 2008?
Your response must be concise. 0.92. What is the ratio of the Value added (constant 2005 US$) in Lesotho in 2004 to that in 2008?
Your answer should be compact. 0.83. What is the ratio of the Value added (constant 2005 US$) in Sudan in 2004 to that in 2008?
Provide a short and direct response. 0.85. What is the ratio of the Value added (constant 2005 US$) of Croatia in 2005 to that in 2006?
Ensure brevity in your answer.  0.96. What is the ratio of the Value added (constant 2005 US$) in Japan in 2005 to that in 2006?
Provide a succinct answer. 0.96. What is the ratio of the Value added (constant 2005 US$) in Lesotho in 2005 to that in 2006?
Offer a very short reply. 0.93. What is the ratio of the Value added (constant 2005 US$) in Sudan in 2005 to that in 2006?
Provide a short and direct response. 1.08. What is the ratio of the Value added (constant 2005 US$) of Croatia in 2005 to that in 2007?
Your response must be concise. 0.91. What is the ratio of the Value added (constant 2005 US$) of Japan in 2005 to that in 2007?
Give a very brief answer. 0.93. What is the ratio of the Value added (constant 2005 US$) in Lesotho in 2005 to that in 2007?
Your response must be concise. 0.87. What is the ratio of the Value added (constant 2005 US$) of Sudan in 2005 to that in 2007?
Your answer should be very brief. 0.86. What is the ratio of the Value added (constant 2005 US$) in Croatia in 2005 to that in 2008?
Ensure brevity in your answer.  0.89. What is the ratio of the Value added (constant 2005 US$) in Japan in 2005 to that in 2008?
Your answer should be compact. 0.94. What is the ratio of the Value added (constant 2005 US$) in Lesotho in 2005 to that in 2008?
Offer a terse response. 0.83. What is the ratio of the Value added (constant 2005 US$) of Sudan in 2005 to that in 2008?
Your answer should be very brief. 0.88. What is the ratio of the Value added (constant 2005 US$) of Croatia in 2006 to that in 2007?
Your response must be concise. 0.95. What is the ratio of the Value added (constant 2005 US$) in Japan in 2006 to that in 2007?
Ensure brevity in your answer.  0.97. What is the ratio of the Value added (constant 2005 US$) of Lesotho in 2006 to that in 2007?
Your response must be concise. 0.94. What is the ratio of the Value added (constant 2005 US$) of Sudan in 2006 to that in 2007?
Your answer should be very brief. 0.8. What is the ratio of the Value added (constant 2005 US$) in Croatia in 2006 to that in 2008?
Your answer should be very brief. 0.94. What is the ratio of the Value added (constant 2005 US$) of Japan in 2006 to that in 2008?
Make the answer very short. 0.97. What is the ratio of the Value added (constant 2005 US$) in Lesotho in 2006 to that in 2008?
Keep it short and to the point. 0.89. What is the ratio of the Value added (constant 2005 US$) of Sudan in 2006 to that in 2008?
Your answer should be compact. 0.82. What is the ratio of the Value added (constant 2005 US$) in Japan in 2007 to that in 2008?
Offer a terse response. 1. What is the ratio of the Value added (constant 2005 US$) in Lesotho in 2007 to that in 2008?
Provide a short and direct response. 0.95. What is the ratio of the Value added (constant 2005 US$) of Sudan in 2007 to that in 2008?
Provide a short and direct response. 1.02. What is the difference between the highest and the second highest Value added (constant 2005 US$) in Croatia?
Your answer should be compact. 2.50e+08. What is the difference between the highest and the second highest Value added (constant 2005 US$) in Japan?
Keep it short and to the point. 6.36e+09. What is the difference between the highest and the second highest Value added (constant 2005 US$) of Lesotho?
Offer a terse response. 2.59e+07. What is the difference between the highest and the second highest Value added (constant 2005 US$) in Sudan?
Your answer should be compact. 1.74e+08. What is the difference between the highest and the lowest Value added (constant 2005 US$) in Croatia?
Provide a short and direct response. 3.04e+09. What is the difference between the highest and the lowest Value added (constant 2005 US$) in Japan?
Your answer should be very brief. 1.81e+11. What is the difference between the highest and the lowest Value added (constant 2005 US$) in Lesotho?
Your answer should be very brief. 1.30e+08. What is the difference between the highest and the lowest Value added (constant 2005 US$) in Sudan?
Ensure brevity in your answer.  2.38e+09. 